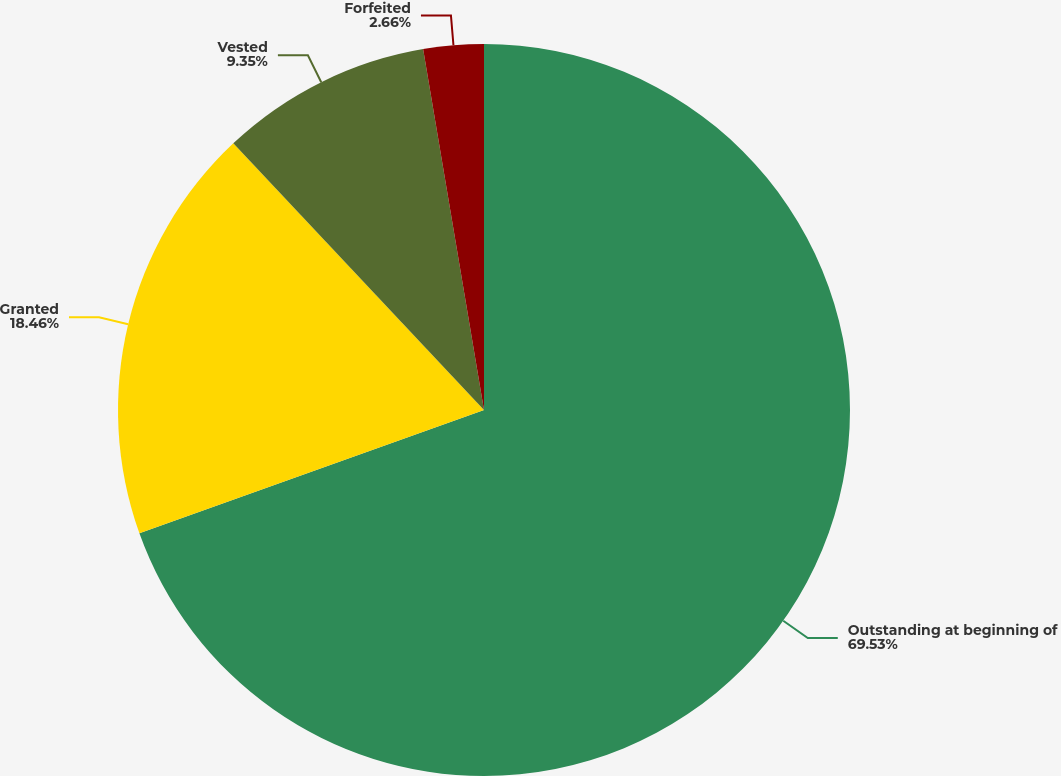Convert chart to OTSL. <chart><loc_0><loc_0><loc_500><loc_500><pie_chart><fcel>Outstanding at beginning of<fcel>Granted<fcel>Vested<fcel>Forfeited<nl><fcel>69.53%<fcel>18.46%<fcel>9.35%<fcel>2.66%<nl></chart> 